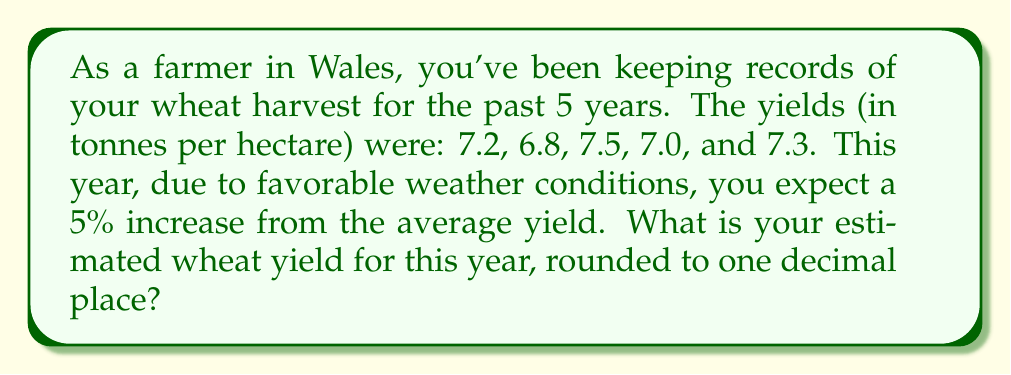Can you answer this question? To solve this problem, we'll follow these steps:

1. Calculate the average yield from the past 5 years:
   $$\text{Average} = \frac{7.2 + 6.8 + 7.5 + 7.0 + 7.3}{5} = \frac{35.8}{5} = 7.16 \text{ tonnes/hectare}$$

2. Calculate the expected 5% increase:
   $$\text{Increase} = 7.16 \times 0.05 = 0.358 \text{ tonnes/hectare}$$

3. Add the increase to the average yield:
   $$\text{Estimated yield} = 7.16 + 0.358 = 7.518 \text{ tonnes/hectare}$$

4. Round the result to one decimal place:
   $$7.518 \approx 7.5 \text{ tonnes/hectare}$$

Therefore, the estimated wheat yield for this year, considering the 5% increase and rounding to one decimal place, is 7.5 tonnes per hectare.
Answer: 7.5 tonnes per hectare 